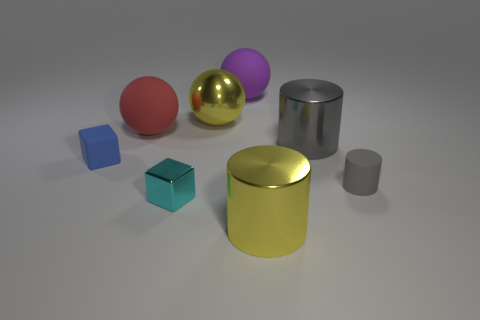There is a gray cylinder that is in front of the small blue matte thing; what is its material? The gray cylinder appears to have a metallic sheen, suggesting it could be made of metal, likely aluminum or steel, given its realistic texture and light reflections. The exact material cannot be confirmed visually alone, but metal is the most plausible guess based on its appearance. 